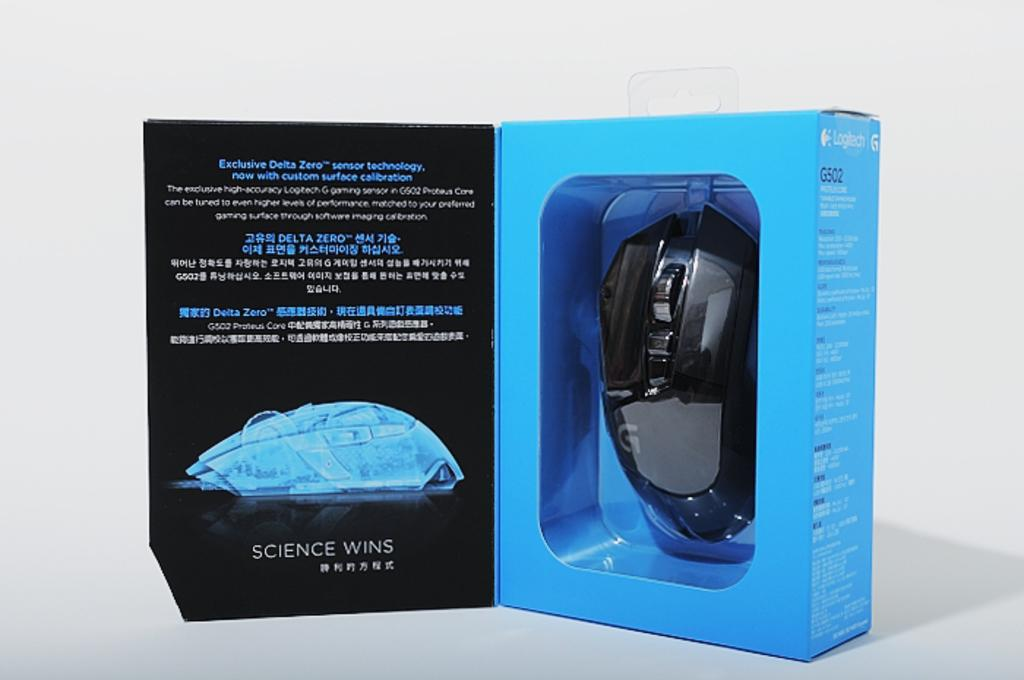What can be seen in the center of the image? There are two boxes containing items in the center of the image. What are the boxes placed on? The boxes are placed on an object. What is written on the boxes? There is text on the boxes. What color is the object in the background of the image? There is a white color object in the background of the image. What type of punishment is being administered to the clam in the image? There is no clam present in the image, and therefore no punishment is being administered. Is the bear visible in the image? There is no bear present in the image. 